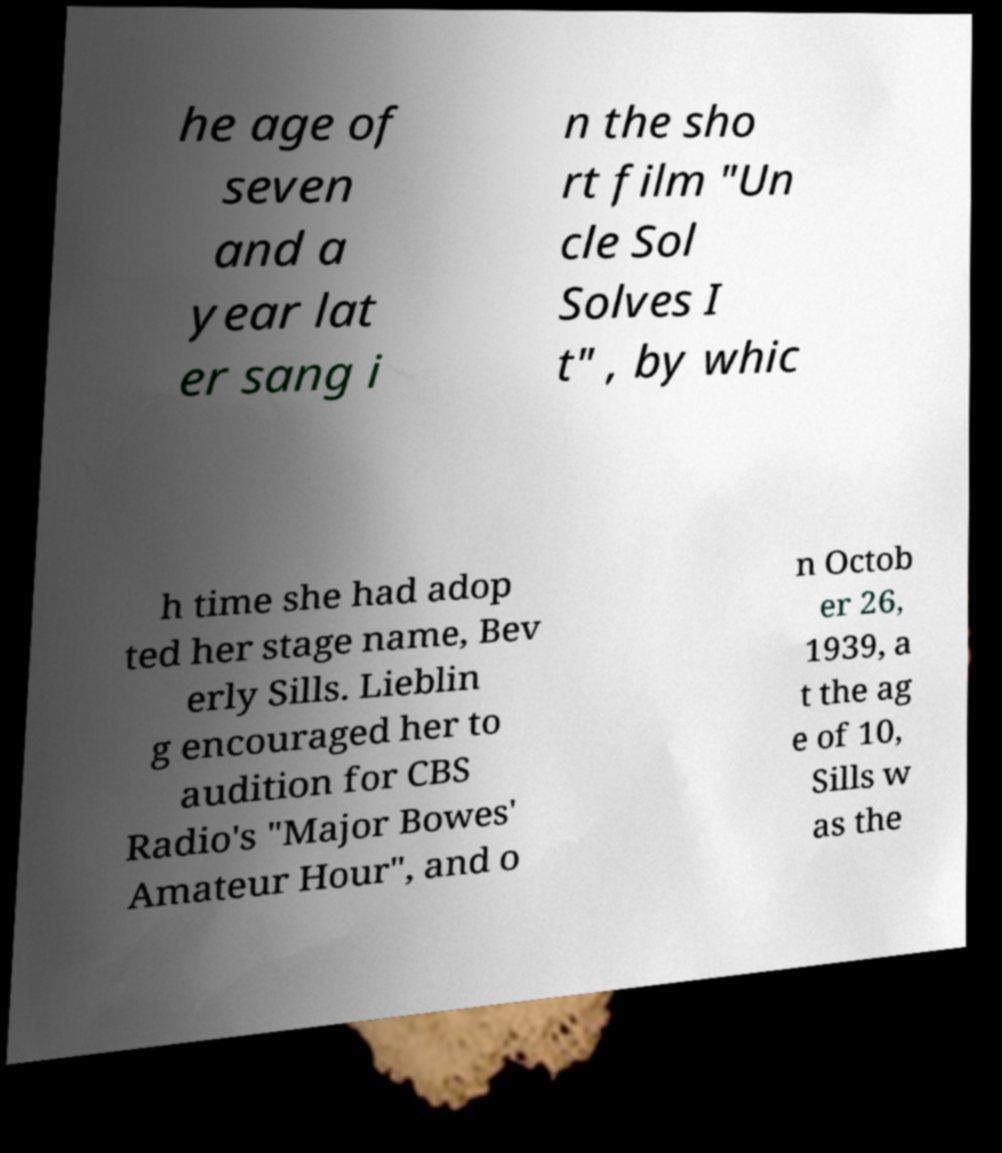Please read and relay the text visible in this image. What does it say? he age of seven and a year lat er sang i n the sho rt film "Un cle Sol Solves I t" , by whic h time she had adop ted her stage name, Bev erly Sills. Lieblin g encouraged her to audition for CBS Radio's "Major Bowes' Amateur Hour", and o n Octob er 26, 1939, a t the ag e of 10, Sills w as the 